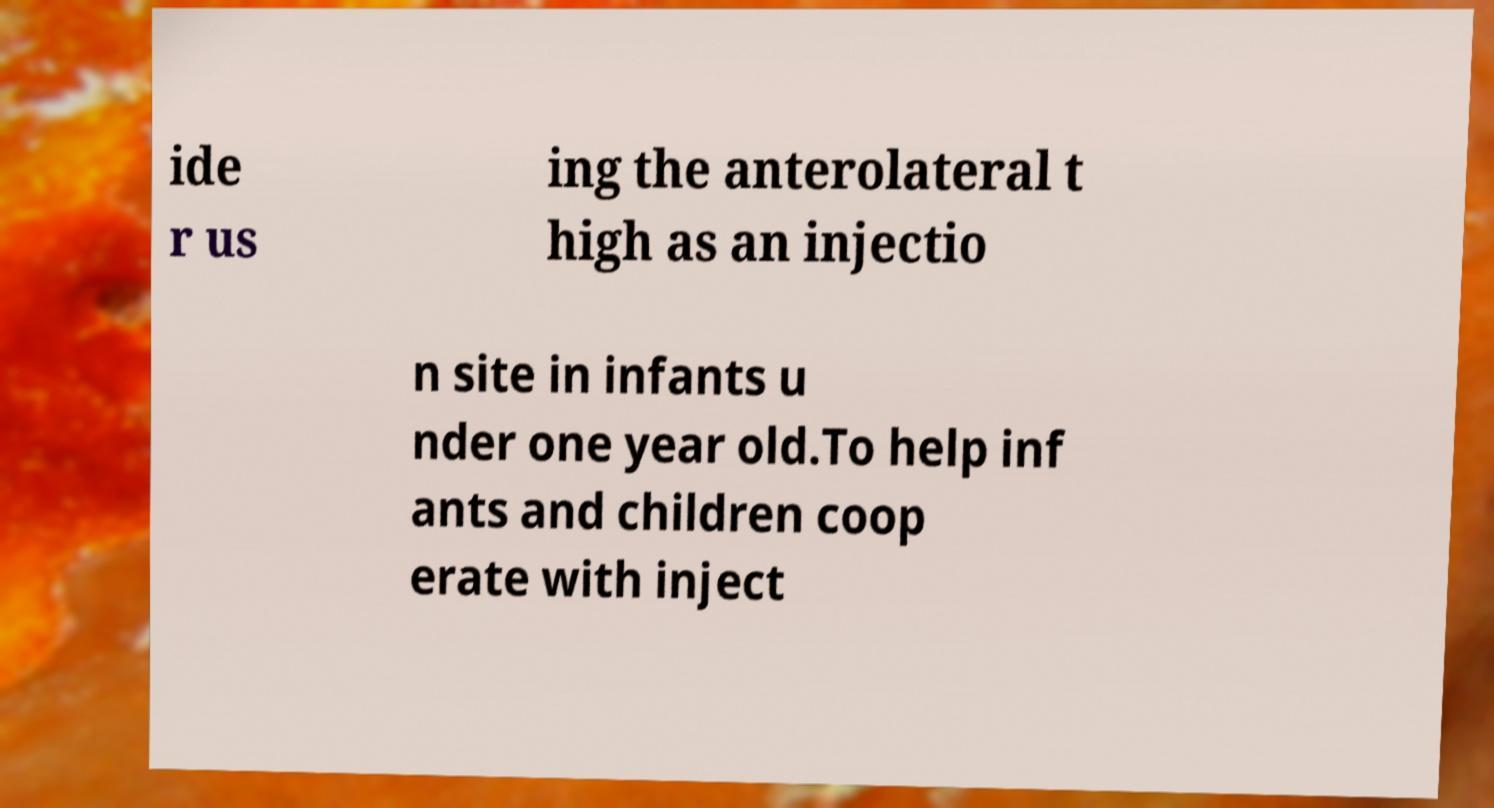Could you extract and type out the text from this image? ide r us ing the anterolateral t high as an injectio n site in infants u nder one year old.To help inf ants and children coop erate with inject 